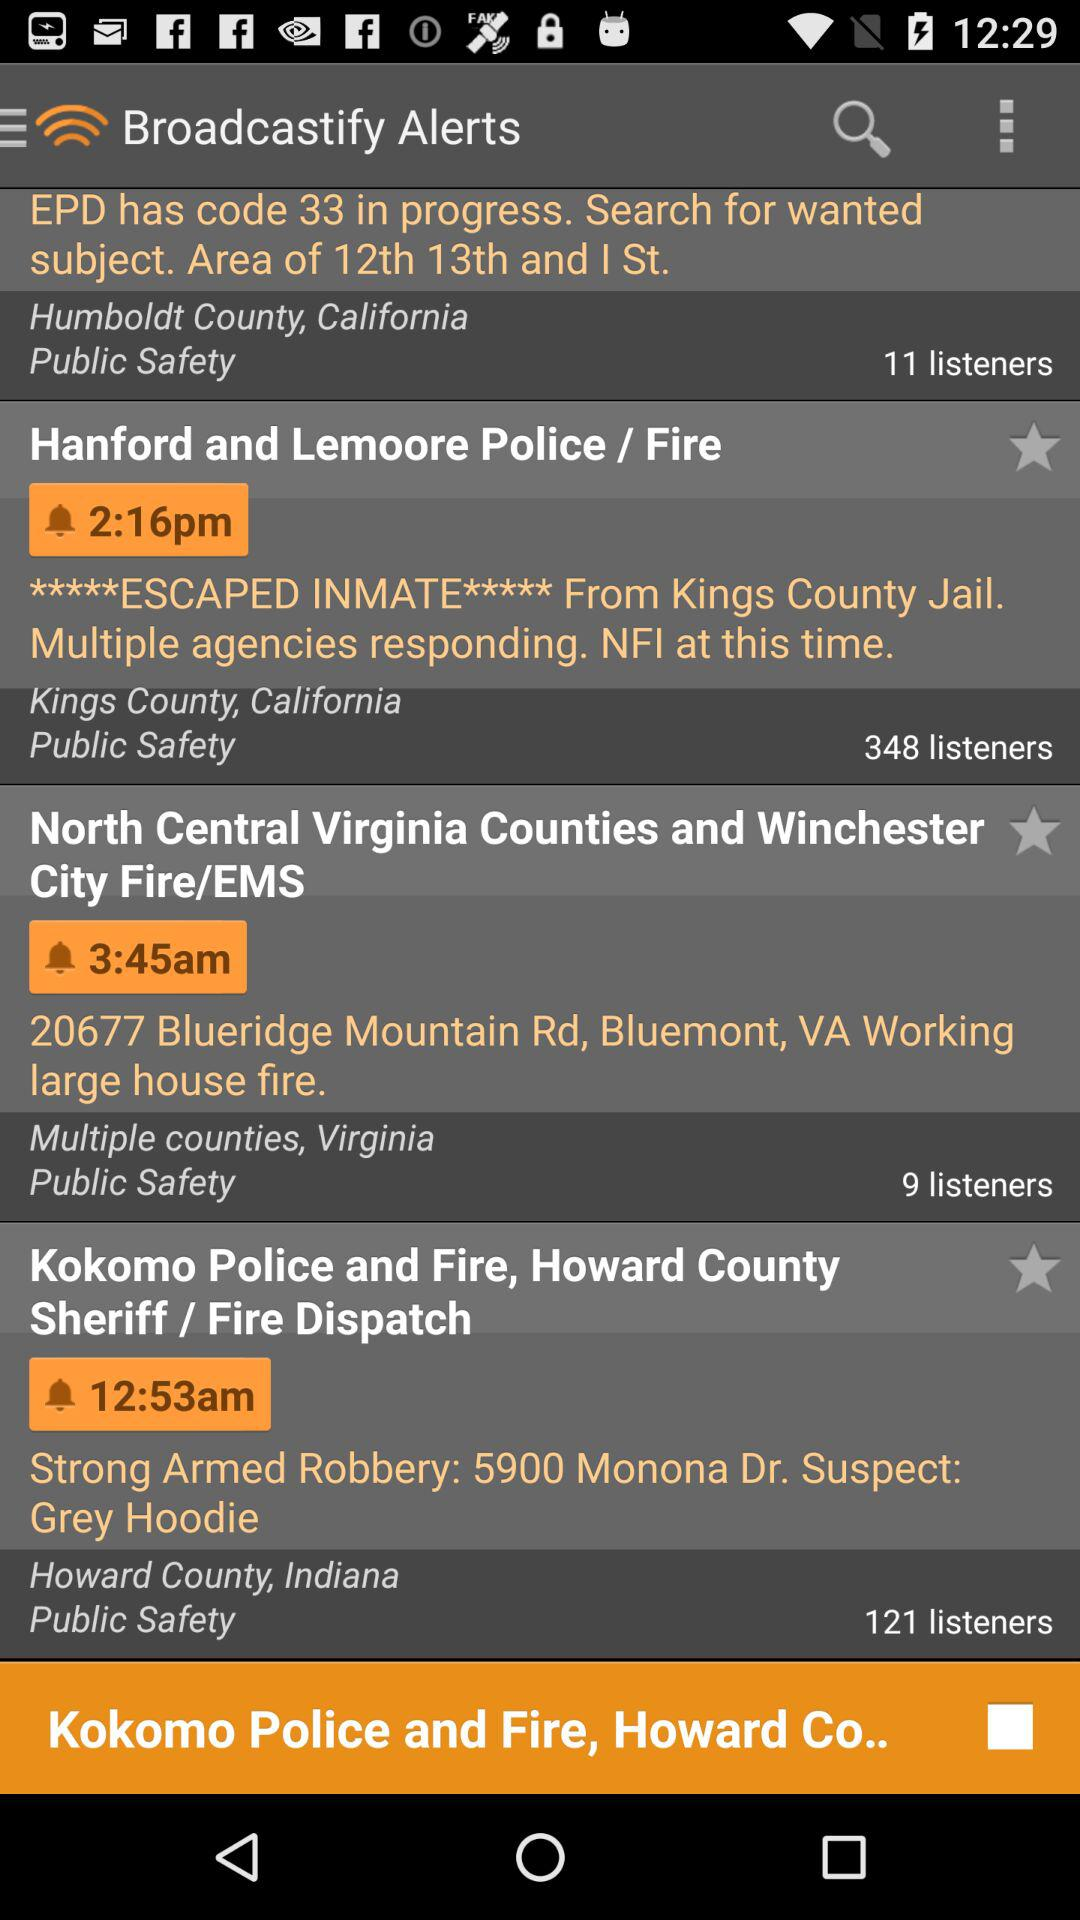What is the broadcast time of "Hanford and Lemoore Police / Fire"? The broadcast time is 2:16pm. 